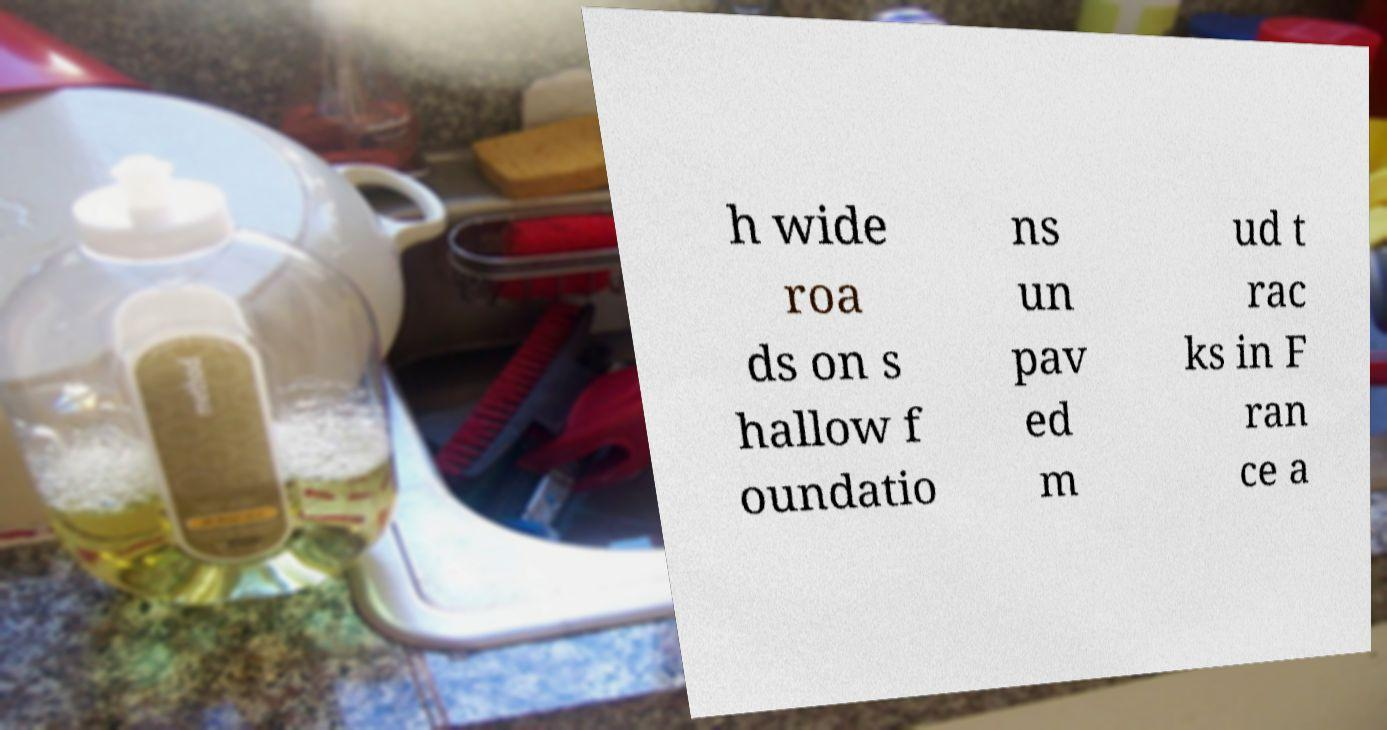Can you accurately transcribe the text from the provided image for me? h wide roa ds on s hallow f oundatio ns un pav ed m ud t rac ks in F ran ce a 